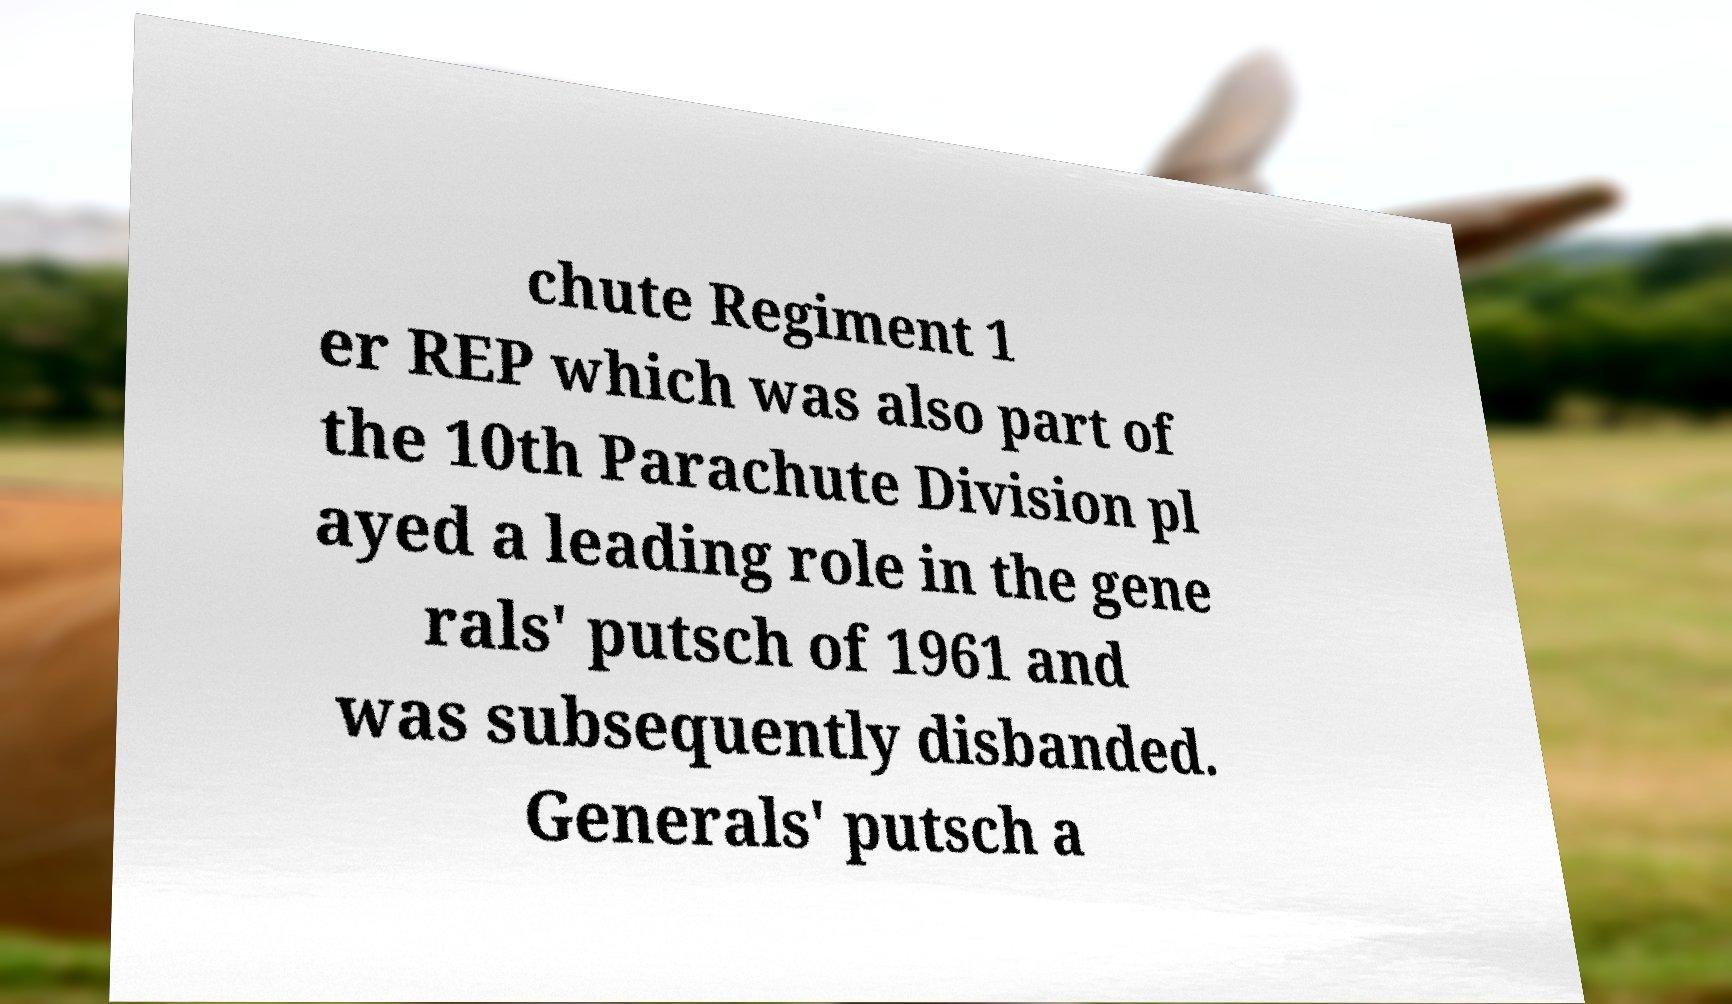Please identify and transcribe the text found in this image. chute Regiment 1 er REP which was also part of the 10th Parachute Division pl ayed a leading role in the gene rals' putsch of 1961 and was subsequently disbanded. Generals' putsch a 